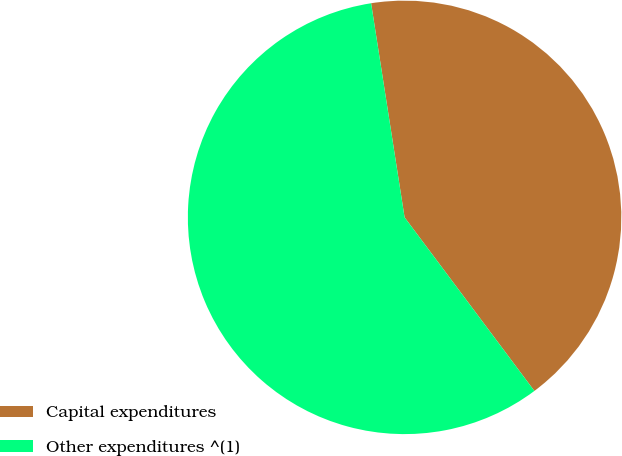Convert chart. <chart><loc_0><loc_0><loc_500><loc_500><pie_chart><fcel>Capital expenditures<fcel>Other expenditures ^(1)<nl><fcel>42.25%<fcel>57.75%<nl></chart> 